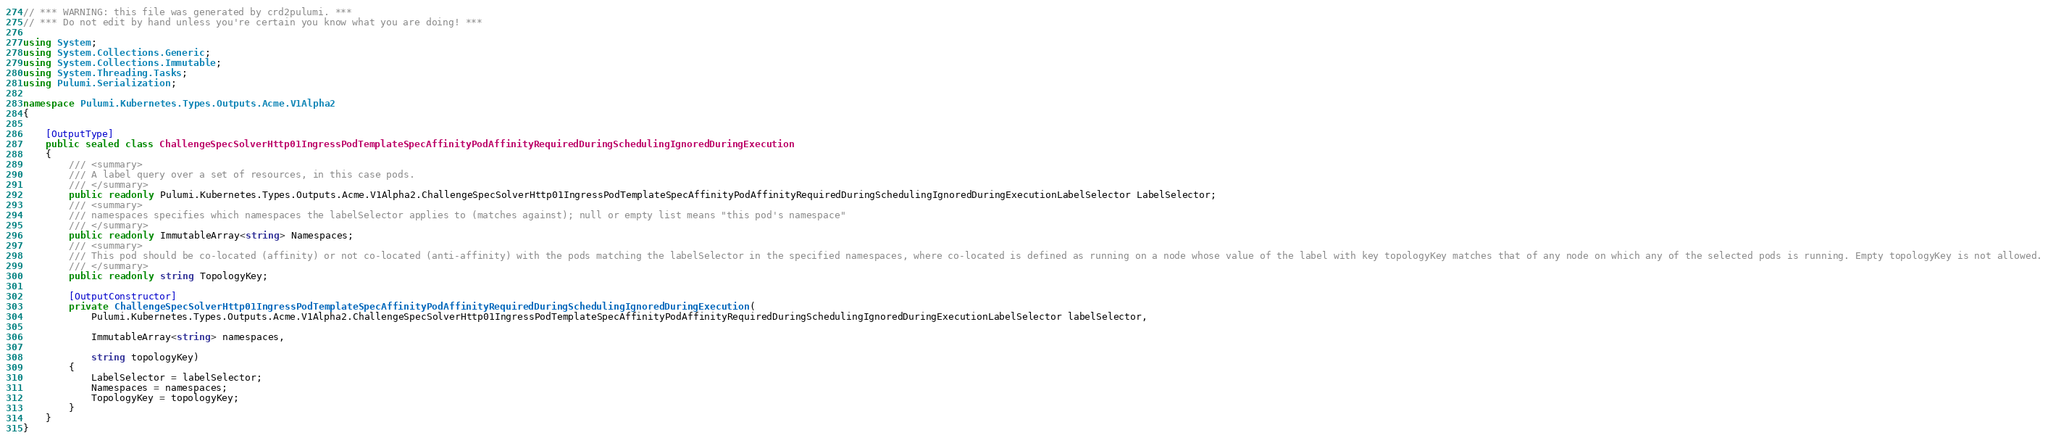<code> <loc_0><loc_0><loc_500><loc_500><_C#_>// *** WARNING: this file was generated by crd2pulumi. ***
// *** Do not edit by hand unless you're certain you know what you are doing! ***

using System;
using System.Collections.Generic;
using System.Collections.Immutable;
using System.Threading.Tasks;
using Pulumi.Serialization;

namespace Pulumi.Kubernetes.Types.Outputs.Acme.V1Alpha2
{

    [OutputType]
    public sealed class ChallengeSpecSolverHttp01IngressPodTemplateSpecAffinityPodAffinityRequiredDuringSchedulingIgnoredDuringExecution
    {
        /// <summary>
        /// A label query over a set of resources, in this case pods.
        /// </summary>
        public readonly Pulumi.Kubernetes.Types.Outputs.Acme.V1Alpha2.ChallengeSpecSolverHttp01IngressPodTemplateSpecAffinityPodAffinityRequiredDuringSchedulingIgnoredDuringExecutionLabelSelector LabelSelector;
        /// <summary>
        /// namespaces specifies which namespaces the labelSelector applies to (matches against); null or empty list means "this pod's namespace"
        /// </summary>
        public readonly ImmutableArray<string> Namespaces;
        /// <summary>
        /// This pod should be co-located (affinity) or not co-located (anti-affinity) with the pods matching the labelSelector in the specified namespaces, where co-located is defined as running on a node whose value of the label with key topologyKey matches that of any node on which any of the selected pods is running. Empty topologyKey is not allowed.
        /// </summary>
        public readonly string TopologyKey;

        [OutputConstructor]
        private ChallengeSpecSolverHttp01IngressPodTemplateSpecAffinityPodAffinityRequiredDuringSchedulingIgnoredDuringExecution(
            Pulumi.Kubernetes.Types.Outputs.Acme.V1Alpha2.ChallengeSpecSolverHttp01IngressPodTemplateSpecAffinityPodAffinityRequiredDuringSchedulingIgnoredDuringExecutionLabelSelector labelSelector,

            ImmutableArray<string> namespaces,

            string topologyKey)
        {
            LabelSelector = labelSelector;
            Namespaces = namespaces;
            TopologyKey = topologyKey;
        }
    }
}
</code> 